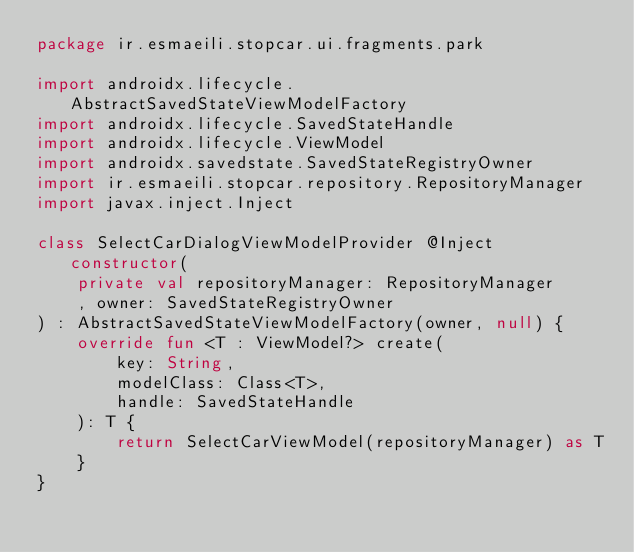<code> <loc_0><loc_0><loc_500><loc_500><_Kotlin_>package ir.esmaeili.stopcar.ui.fragments.park

import androidx.lifecycle.AbstractSavedStateViewModelFactory
import androidx.lifecycle.SavedStateHandle
import androidx.lifecycle.ViewModel
import androidx.savedstate.SavedStateRegistryOwner
import ir.esmaeili.stopcar.repository.RepositoryManager
import javax.inject.Inject

class SelectCarDialogViewModelProvider @Inject constructor(
    private val repositoryManager: RepositoryManager
    , owner: SavedStateRegistryOwner
) : AbstractSavedStateViewModelFactory(owner, null) {
    override fun <T : ViewModel?> create(
        key: String,
        modelClass: Class<T>,
        handle: SavedStateHandle
    ): T {
        return SelectCarViewModel(repositoryManager) as T
    }
}</code> 